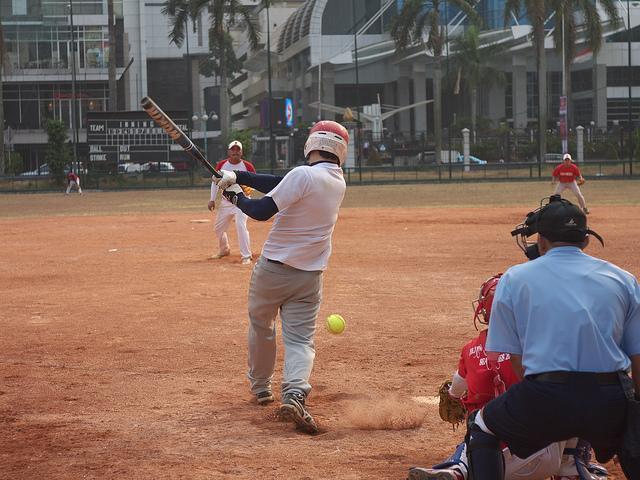How many people are there?
Give a very brief answer. 4. 